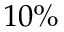Convert formula to latex. <formula><loc_0><loc_0><loc_500><loc_500>1 0 \%</formula> 